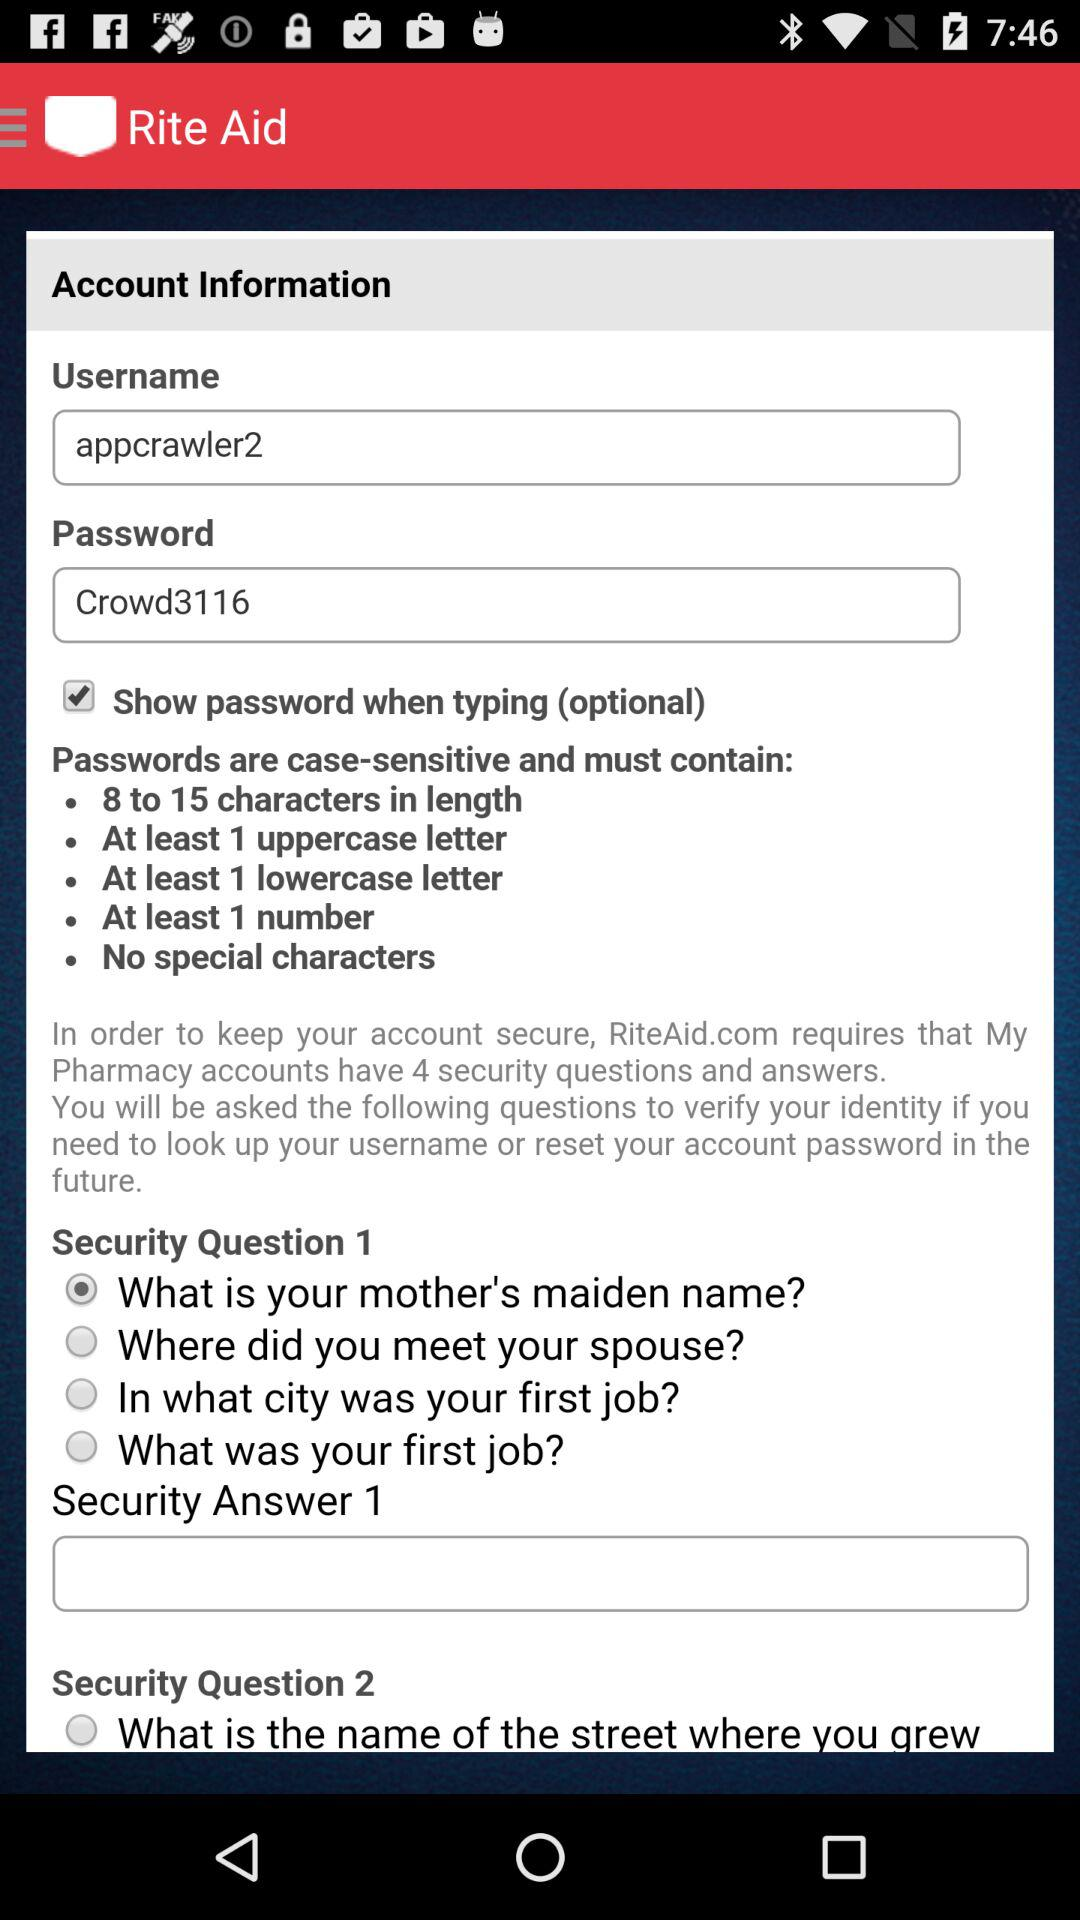What is the password? The password is "Crowd3116". 